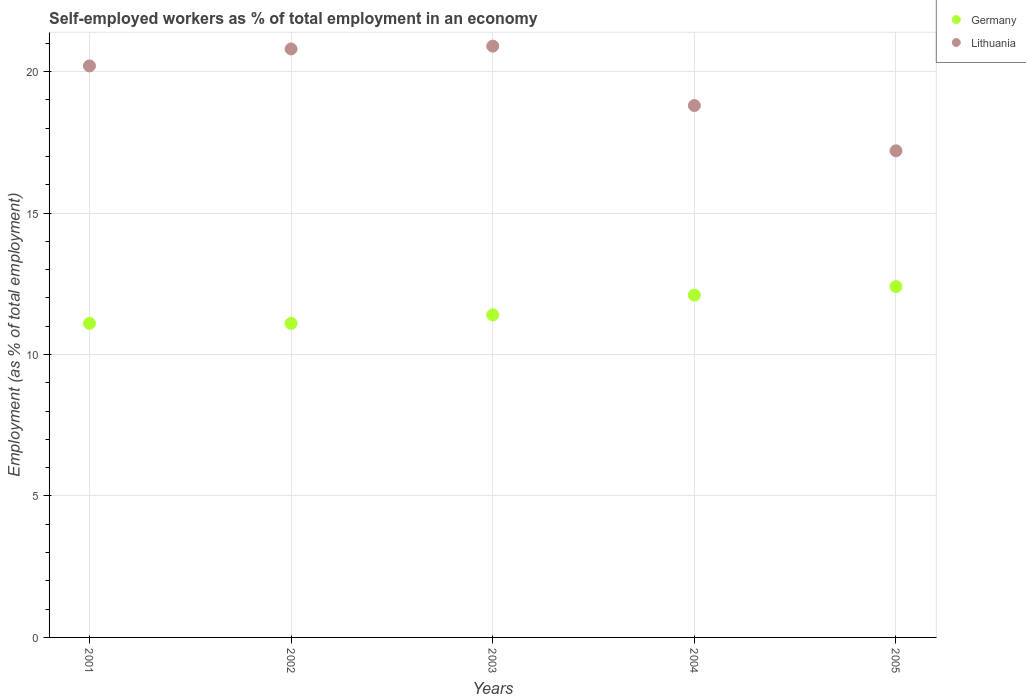What is the percentage of self-employed workers in Germany in 2004?
Keep it short and to the point. 12.1. Across all years, what is the maximum percentage of self-employed workers in Germany?
Provide a succinct answer. 12.4. Across all years, what is the minimum percentage of self-employed workers in Germany?
Your answer should be compact. 11.1. In which year was the percentage of self-employed workers in Germany maximum?
Your answer should be very brief. 2005. What is the total percentage of self-employed workers in Lithuania in the graph?
Ensure brevity in your answer.  97.9. What is the difference between the percentage of self-employed workers in Lithuania in 2002 and that in 2003?
Make the answer very short. -0.1. What is the difference between the percentage of self-employed workers in Lithuania in 2004 and the percentage of self-employed workers in Germany in 2001?
Keep it short and to the point. 7.7. What is the average percentage of self-employed workers in Lithuania per year?
Give a very brief answer. 19.58. In the year 2003, what is the difference between the percentage of self-employed workers in Germany and percentage of self-employed workers in Lithuania?
Provide a short and direct response. -9.5. What is the ratio of the percentage of self-employed workers in Germany in 2002 to that in 2003?
Keep it short and to the point. 0.97. Is the percentage of self-employed workers in Germany in 2003 less than that in 2004?
Offer a terse response. Yes. Is the difference between the percentage of self-employed workers in Germany in 2001 and 2005 greater than the difference between the percentage of self-employed workers in Lithuania in 2001 and 2005?
Ensure brevity in your answer.  No. What is the difference between the highest and the second highest percentage of self-employed workers in Germany?
Offer a very short reply. 0.3. What is the difference between the highest and the lowest percentage of self-employed workers in Germany?
Make the answer very short. 1.3. In how many years, is the percentage of self-employed workers in Lithuania greater than the average percentage of self-employed workers in Lithuania taken over all years?
Your response must be concise. 3. Is the sum of the percentage of self-employed workers in Lithuania in 2001 and 2005 greater than the maximum percentage of self-employed workers in Germany across all years?
Give a very brief answer. Yes. Does the percentage of self-employed workers in Lithuania monotonically increase over the years?
Offer a very short reply. No. Is the percentage of self-employed workers in Lithuania strictly greater than the percentage of self-employed workers in Germany over the years?
Provide a short and direct response. Yes. How many dotlines are there?
Your answer should be compact. 2. Are the values on the major ticks of Y-axis written in scientific E-notation?
Give a very brief answer. No. Does the graph contain any zero values?
Your answer should be compact. No. Where does the legend appear in the graph?
Your answer should be compact. Top right. How many legend labels are there?
Your answer should be very brief. 2. What is the title of the graph?
Offer a terse response. Self-employed workers as % of total employment in an economy. Does "Bermuda" appear as one of the legend labels in the graph?
Your response must be concise. No. What is the label or title of the X-axis?
Give a very brief answer. Years. What is the label or title of the Y-axis?
Keep it short and to the point. Employment (as % of total employment). What is the Employment (as % of total employment) in Germany in 2001?
Give a very brief answer. 11.1. What is the Employment (as % of total employment) of Lithuania in 2001?
Offer a very short reply. 20.2. What is the Employment (as % of total employment) of Germany in 2002?
Offer a very short reply. 11.1. What is the Employment (as % of total employment) in Lithuania in 2002?
Make the answer very short. 20.8. What is the Employment (as % of total employment) in Germany in 2003?
Provide a short and direct response. 11.4. What is the Employment (as % of total employment) in Lithuania in 2003?
Provide a succinct answer. 20.9. What is the Employment (as % of total employment) of Germany in 2004?
Ensure brevity in your answer.  12.1. What is the Employment (as % of total employment) in Lithuania in 2004?
Your response must be concise. 18.8. What is the Employment (as % of total employment) of Germany in 2005?
Offer a very short reply. 12.4. What is the Employment (as % of total employment) of Lithuania in 2005?
Your answer should be compact. 17.2. Across all years, what is the maximum Employment (as % of total employment) of Germany?
Keep it short and to the point. 12.4. Across all years, what is the maximum Employment (as % of total employment) of Lithuania?
Ensure brevity in your answer.  20.9. Across all years, what is the minimum Employment (as % of total employment) in Germany?
Ensure brevity in your answer.  11.1. Across all years, what is the minimum Employment (as % of total employment) of Lithuania?
Offer a terse response. 17.2. What is the total Employment (as % of total employment) of Germany in the graph?
Ensure brevity in your answer.  58.1. What is the total Employment (as % of total employment) in Lithuania in the graph?
Your answer should be very brief. 97.9. What is the difference between the Employment (as % of total employment) in Germany in 2001 and that in 2003?
Keep it short and to the point. -0.3. What is the difference between the Employment (as % of total employment) of Germany in 2001 and that in 2004?
Provide a short and direct response. -1. What is the difference between the Employment (as % of total employment) in Lithuania in 2001 and that in 2004?
Your response must be concise. 1.4. What is the difference between the Employment (as % of total employment) in Germany in 2001 and that in 2005?
Provide a succinct answer. -1.3. What is the difference between the Employment (as % of total employment) in Germany in 2002 and that in 2003?
Offer a terse response. -0.3. What is the difference between the Employment (as % of total employment) in Lithuania in 2002 and that in 2003?
Give a very brief answer. -0.1. What is the difference between the Employment (as % of total employment) of Germany in 2002 and that in 2004?
Your answer should be compact. -1. What is the difference between the Employment (as % of total employment) in Lithuania in 2002 and that in 2004?
Your answer should be compact. 2. What is the difference between the Employment (as % of total employment) of Lithuania in 2002 and that in 2005?
Your answer should be very brief. 3.6. What is the difference between the Employment (as % of total employment) of Lithuania in 2003 and that in 2004?
Make the answer very short. 2.1. What is the difference between the Employment (as % of total employment) of Germany in 2003 and that in 2005?
Keep it short and to the point. -1. What is the difference between the Employment (as % of total employment) in Lithuania in 2003 and that in 2005?
Provide a succinct answer. 3.7. What is the difference between the Employment (as % of total employment) in Germany in 2001 and the Employment (as % of total employment) in Lithuania in 2005?
Make the answer very short. -6.1. What is the difference between the Employment (as % of total employment) of Germany in 2002 and the Employment (as % of total employment) of Lithuania in 2004?
Offer a terse response. -7.7. What is the difference between the Employment (as % of total employment) of Germany in 2003 and the Employment (as % of total employment) of Lithuania in 2004?
Your answer should be very brief. -7.4. What is the difference between the Employment (as % of total employment) of Germany in 2003 and the Employment (as % of total employment) of Lithuania in 2005?
Ensure brevity in your answer.  -5.8. What is the average Employment (as % of total employment) of Germany per year?
Keep it short and to the point. 11.62. What is the average Employment (as % of total employment) of Lithuania per year?
Make the answer very short. 19.58. In the year 2001, what is the difference between the Employment (as % of total employment) of Germany and Employment (as % of total employment) of Lithuania?
Keep it short and to the point. -9.1. In the year 2002, what is the difference between the Employment (as % of total employment) in Germany and Employment (as % of total employment) in Lithuania?
Your answer should be very brief. -9.7. In the year 2004, what is the difference between the Employment (as % of total employment) in Germany and Employment (as % of total employment) in Lithuania?
Provide a succinct answer. -6.7. What is the ratio of the Employment (as % of total employment) in Lithuania in 2001 to that in 2002?
Offer a very short reply. 0.97. What is the ratio of the Employment (as % of total employment) in Germany in 2001 to that in 2003?
Keep it short and to the point. 0.97. What is the ratio of the Employment (as % of total employment) of Lithuania in 2001 to that in 2003?
Offer a terse response. 0.97. What is the ratio of the Employment (as % of total employment) of Germany in 2001 to that in 2004?
Your answer should be compact. 0.92. What is the ratio of the Employment (as % of total employment) of Lithuania in 2001 to that in 2004?
Give a very brief answer. 1.07. What is the ratio of the Employment (as % of total employment) of Germany in 2001 to that in 2005?
Your answer should be very brief. 0.9. What is the ratio of the Employment (as % of total employment) of Lithuania in 2001 to that in 2005?
Provide a succinct answer. 1.17. What is the ratio of the Employment (as % of total employment) in Germany in 2002 to that in 2003?
Provide a succinct answer. 0.97. What is the ratio of the Employment (as % of total employment) of Lithuania in 2002 to that in 2003?
Keep it short and to the point. 1. What is the ratio of the Employment (as % of total employment) in Germany in 2002 to that in 2004?
Provide a succinct answer. 0.92. What is the ratio of the Employment (as % of total employment) of Lithuania in 2002 to that in 2004?
Provide a succinct answer. 1.11. What is the ratio of the Employment (as % of total employment) in Germany in 2002 to that in 2005?
Give a very brief answer. 0.9. What is the ratio of the Employment (as % of total employment) in Lithuania in 2002 to that in 2005?
Your answer should be very brief. 1.21. What is the ratio of the Employment (as % of total employment) of Germany in 2003 to that in 2004?
Ensure brevity in your answer.  0.94. What is the ratio of the Employment (as % of total employment) of Lithuania in 2003 to that in 2004?
Ensure brevity in your answer.  1.11. What is the ratio of the Employment (as % of total employment) in Germany in 2003 to that in 2005?
Ensure brevity in your answer.  0.92. What is the ratio of the Employment (as % of total employment) in Lithuania in 2003 to that in 2005?
Your answer should be very brief. 1.22. What is the ratio of the Employment (as % of total employment) of Germany in 2004 to that in 2005?
Provide a short and direct response. 0.98. What is the ratio of the Employment (as % of total employment) of Lithuania in 2004 to that in 2005?
Keep it short and to the point. 1.09. What is the difference between the highest and the lowest Employment (as % of total employment) in Germany?
Give a very brief answer. 1.3. 